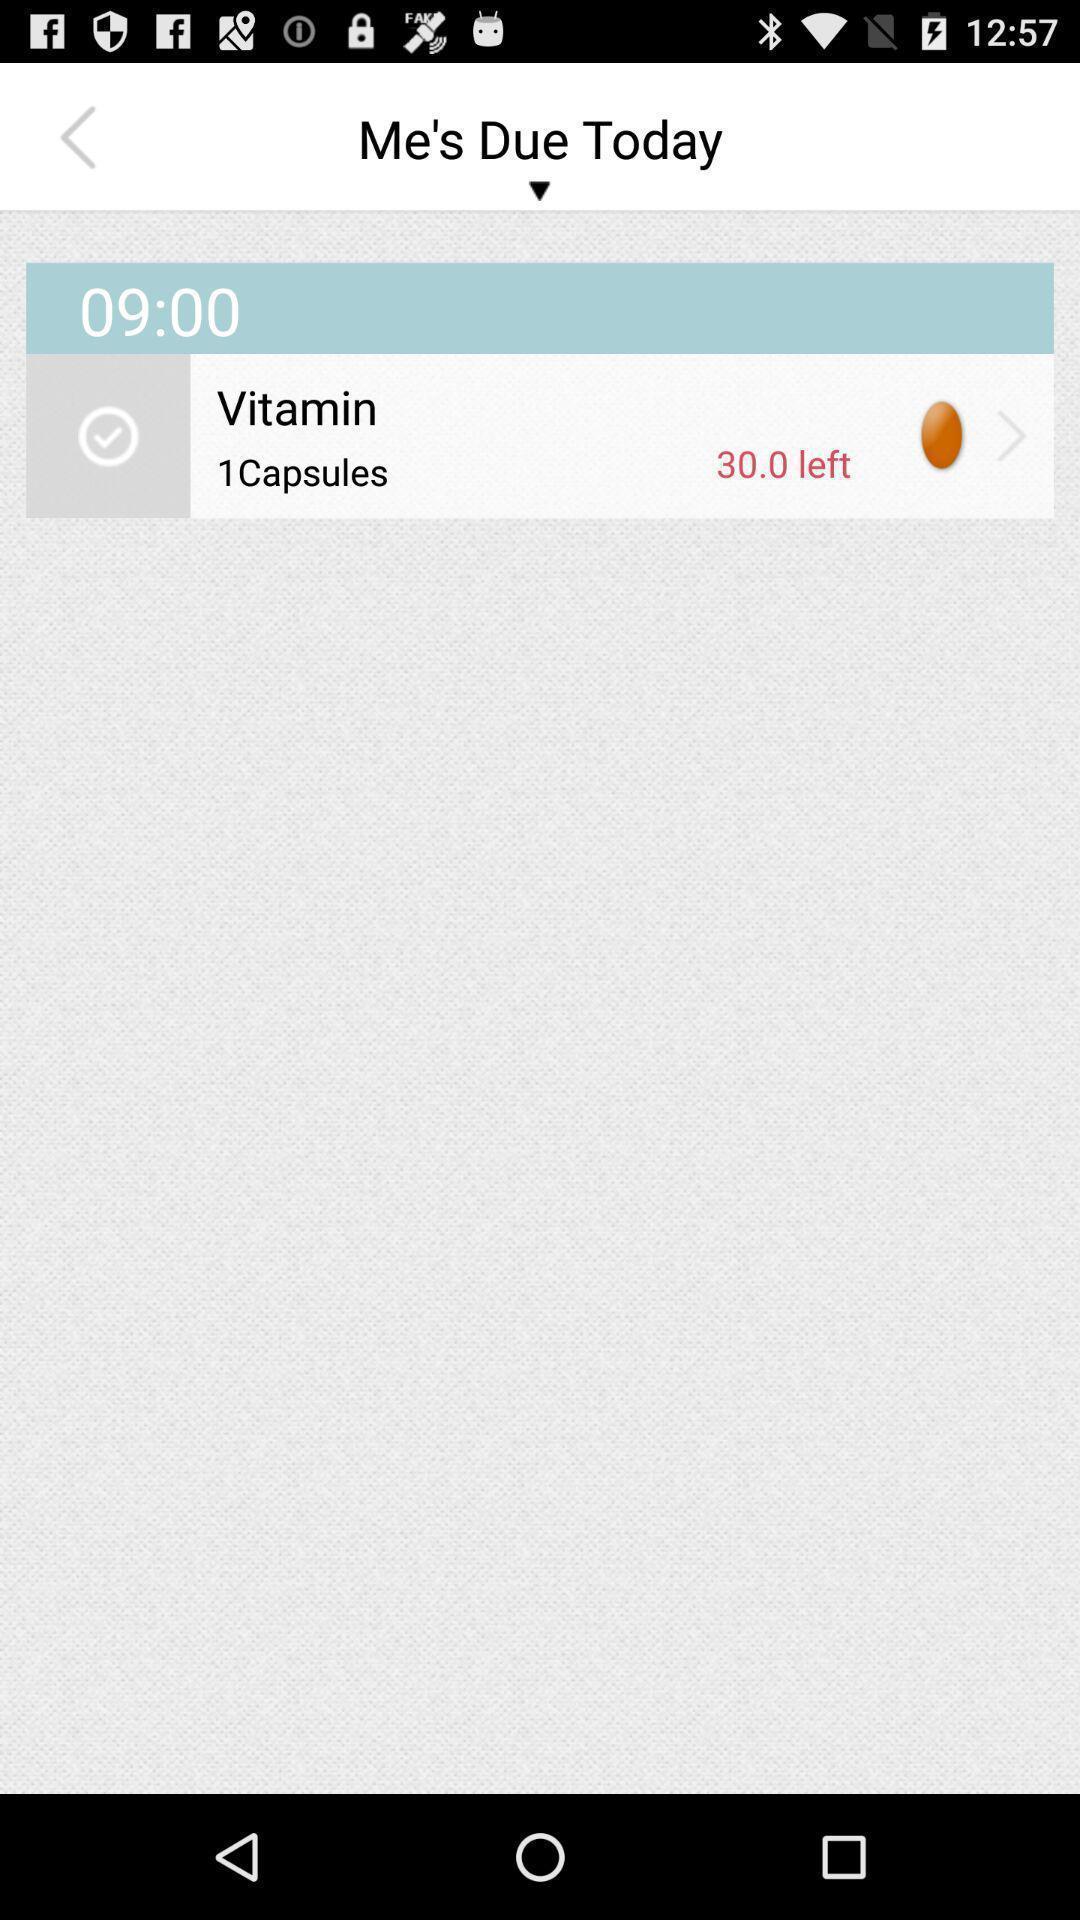Describe the key features of this screenshot. Vitamin data page in a health app. 